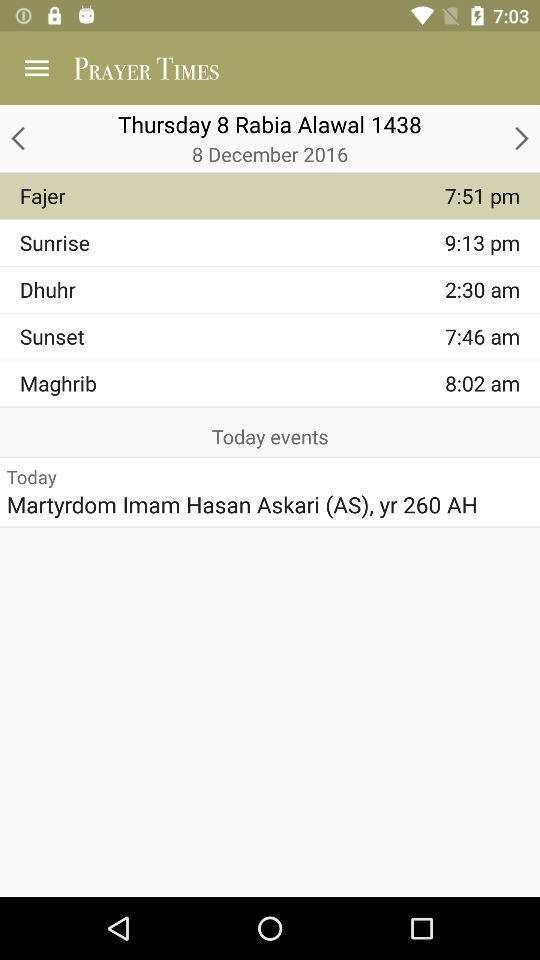What is the time of the Fajer prayer? The time of the Fajer prayer is 7:51 p.m. 